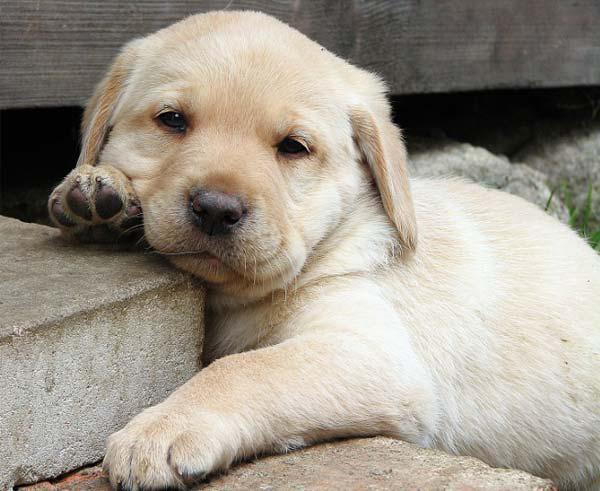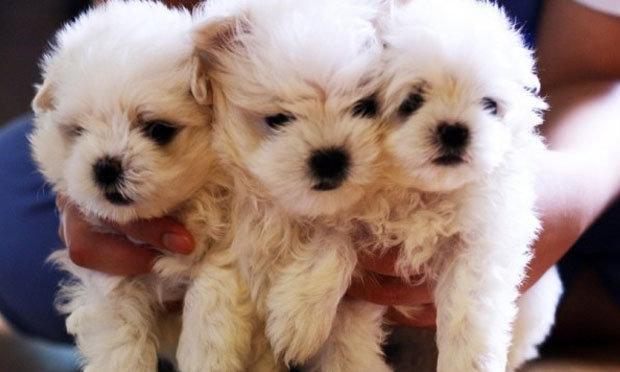The first image is the image on the left, the second image is the image on the right. Evaluate the accuracy of this statement regarding the images: "There are at least three dogs.". Is it true? Answer yes or no. Yes. The first image is the image on the left, the second image is the image on the right. Considering the images on both sides, is "In one of the images there are at least two puppies right next to each other." valid? Answer yes or no. Yes. 